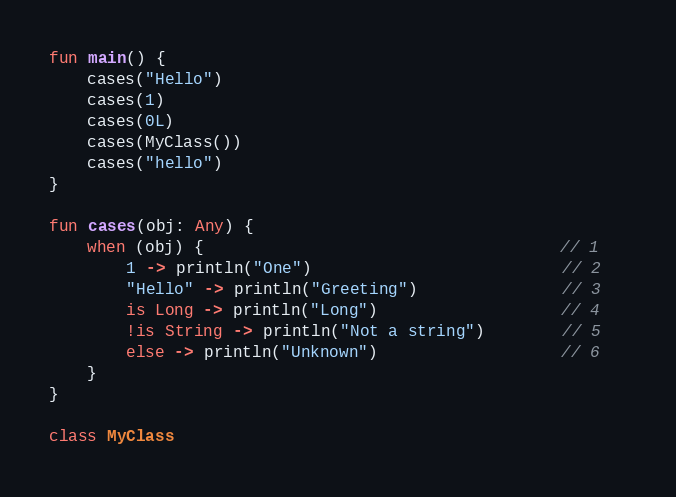<code> <loc_0><loc_0><loc_500><loc_500><_Kotlin_>fun main() {
    cases("Hello")
    cases(1)
    cases(0L)
    cases(MyClass())
    cases("hello")
}

fun cases(obj: Any) {                                
    when (obj) {                                     // 1   
        1 -> println("One")                          // 2
        "Hello" -> println("Greeting")               // 3
        is Long -> println("Long")                   // 4
        !is String -> println("Not a string")        // 5
        else -> println("Unknown")                   // 6
    }   
}

class MyClass</code> 